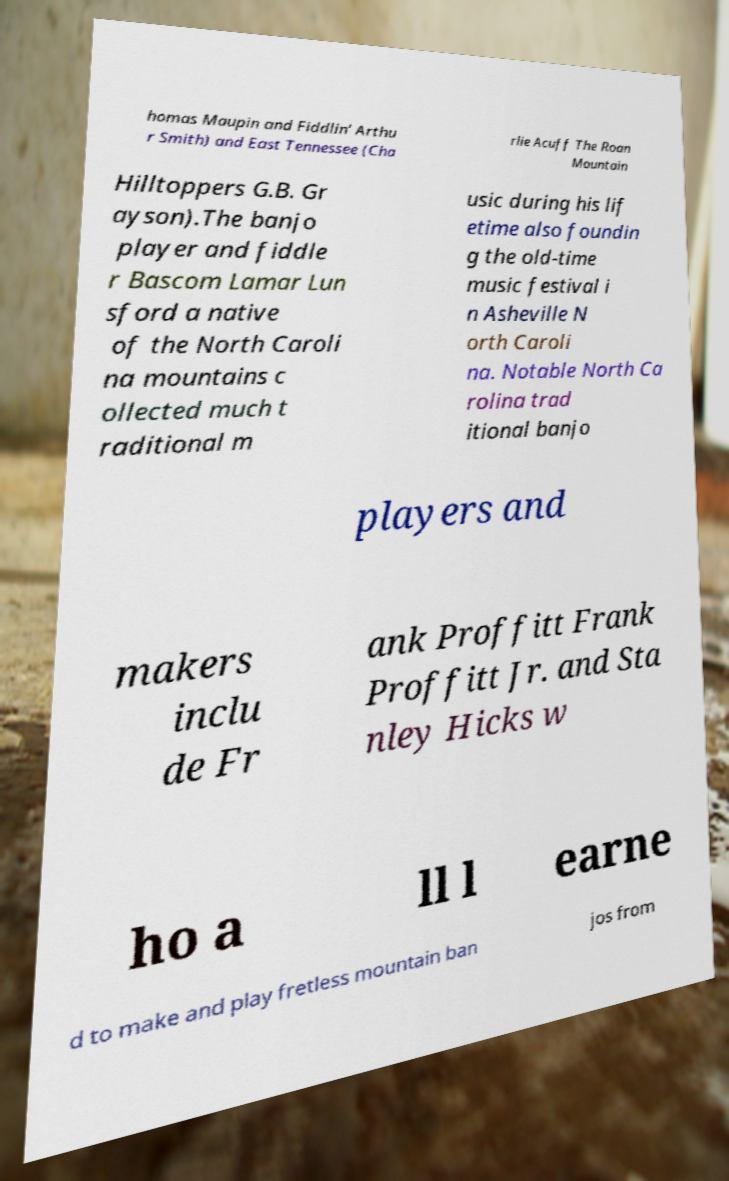Could you extract and type out the text from this image? homas Maupin and Fiddlin' Arthu r Smith) and East Tennessee (Cha rlie Acuff The Roan Mountain Hilltoppers G.B. Gr ayson).The banjo player and fiddle r Bascom Lamar Lun sford a native of the North Caroli na mountains c ollected much t raditional m usic during his lif etime also foundin g the old-time music festival i n Asheville N orth Caroli na. Notable North Ca rolina trad itional banjo players and makers inclu de Fr ank Proffitt Frank Proffitt Jr. and Sta nley Hicks w ho a ll l earne d to make and play fretless mountain ban jos from 